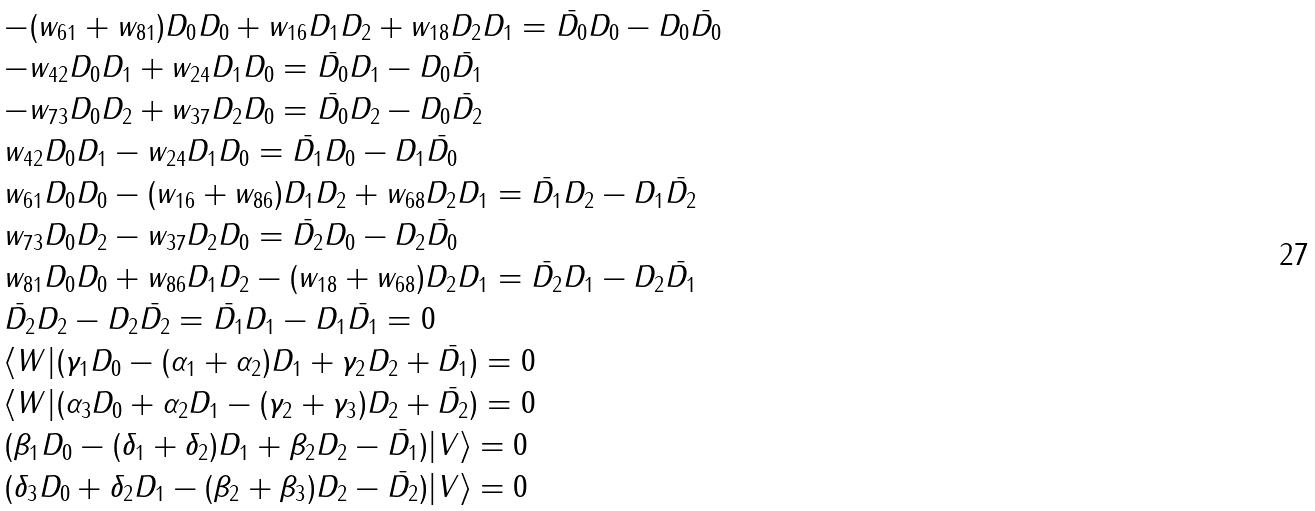<formula> <loc_0><loc_0><loc_500><loc_500>\begin{array} { l } - ( w _ { 6 1 } + w _ { 8 1 } ) D _ { 0 } D _ { 0 } + w _ { 1 6 } D _ { 1 } D _ { 2 } + w _ { 1 8 } D _ { 2 } D _ { 1 } = \bar { D _ { 0 } } D _ { 0 } - D _ { 0 } \bar { D _ { 0 } } \\ - w _ { 4 2 } D _ { 0 } D _ { 1 } + w _ { 2 4 } D _ { 1 } D _ { 0 } = \bar { D _ { 0 } } D _ { 1 } - D _ { 0 } \bar { D _ { 1 } } \\ - w _ { 7 3 } D _ { 0 } D _ { 2 } + w _ { 3 7 } D _ { 2 } D _ { 0 } = \bar { D _ { 0 } } D _ { 2 } - D _ { 0 } \bar { D _ { 2 } } \\ w _ { 4 2 } D _ { 0 } D _ { 1 } - w _ { 2 4 } D _ { 1 } D _ { 0 } = \bar { D _ { 1 } } D _ { 0 } - D _ { 1 } \bar { D _ { 0 } } \\ w _ { 6 1 } D _ { 0 } D _ { 0 } - ( w _ { 1 6 } + w _ { 8 6 } ) D _ { 1 } D _ { 2 } + w _ { 6 8 } D _ { 2 } D _ { 1 } = \bar { D _ { 1 } } D _ { 2 } - D _ { 1 } \bar { D _ { 2 } } \\ w _ { 7 3 } D _ { 0 } D _ { 2 } - w _ { 3 7 } D _ { 2 } D _ { 0 } = \bar { D _ { 2 } } D _ { 0 } - D _ { 2 } \bar { D _ { 0 } } \\ w _ { 8 1 } D _ { 0 } D _ { 0 } + w _ { 8 6 } D _ { 1 } D _ { 2 } - ( w _ { 1 8 } + w _ { 6 8 } ) D _ { 2 } D _ { 1 } = \bar { D _ { 2 } } D _ { 1 } - D _ { 2 } \bar { D _ { 1 } } \\ \bar { D _ { 2 } } D _ { 2 } - D _ { 2 } \bar { D _ { 2 } } = \bar { D _ { 1 } } D _ { 1 } - D _ { 1 } \bar { D _ { 1 } } = 0 \\ \langle W | ( \gamma _ { 1 } D _ { 0 } - ( \alpha _ { 1 } + \alpha _ { 2 } ) D _ { 1 } + \gamma _ { 2 } D _ { 2 } + \bar { D _ { 1 } } ) = 0 \\ \langle W | ( \alpha _ { 3 } D _ { 0 } + \alpha _ { 2 } D _ { 1 } - ( \gamma _ { 2 } + \gamma _ { 3 } ) D _ { 2 } + \bar { D _ { 2 } } ) = 0 \\ ( \beta _ { 1 } D _ { 0 } - ( \delta _ { 1 } + \delta _ { 2 } ) D _ { 1 } + \beta _ { 2 } D _ { 2 } - \bar { D _ { 1 } } ) | V \rangle = 0 \\ ( \delta _ { 3 } D _ { 0 } + \delta _ { 2 } D _ { 1 } - ( \beta _ { 2 } + \beta _ { 3 } ) D _ { 2 } - \bar { D _ { 2 } } ) | V \rangle = 0 \end{array}</formula> 